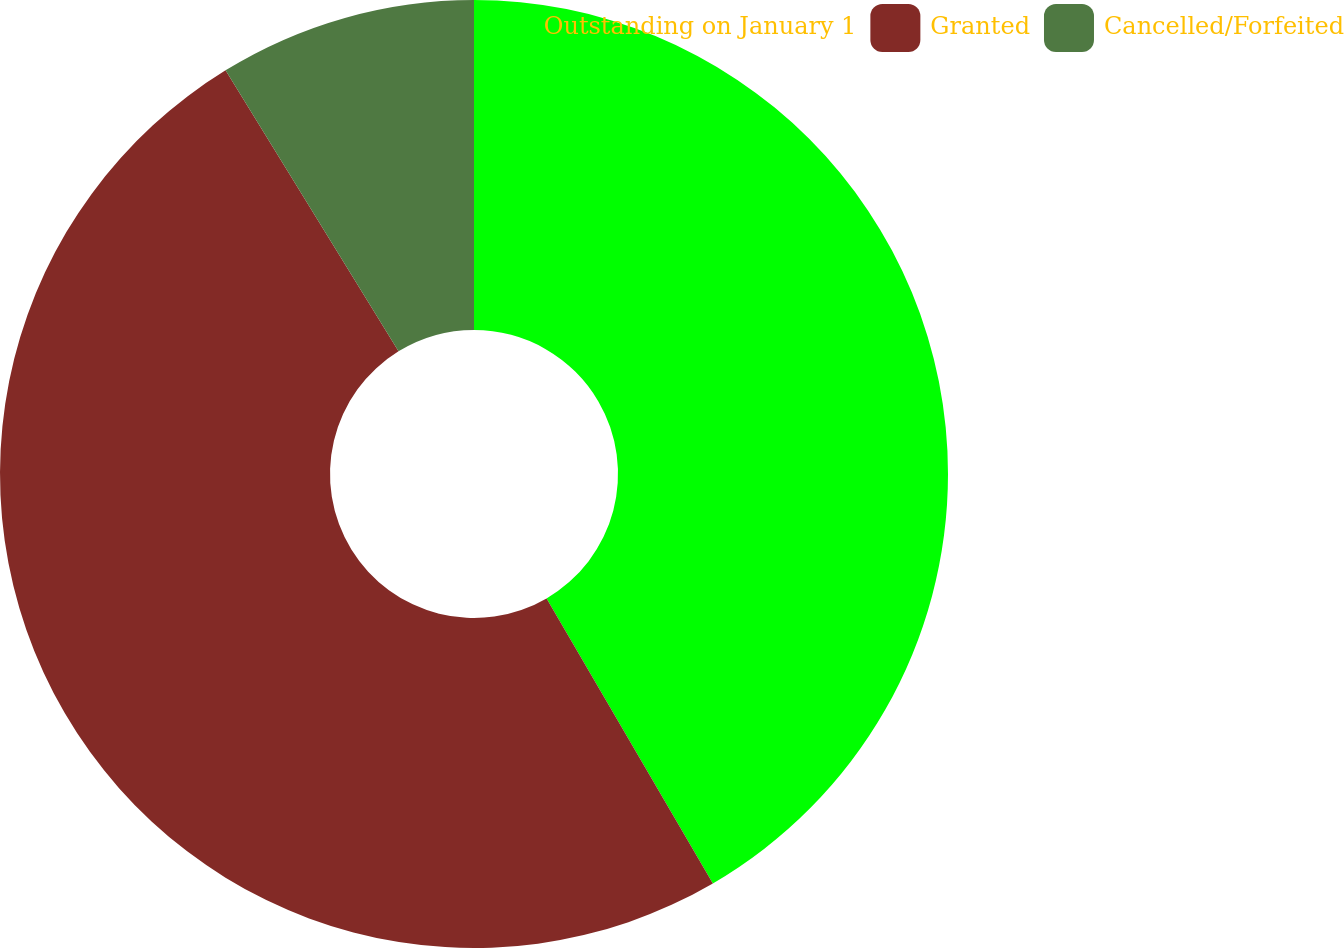Convert chart to OTSL. <chart><loc_0><loc_0><loc_500><loc_500><pie_chart><fcel>Outstanding on January 1<fcel>Granted<fcel>Cancelled/Forfeited<nl><fcel>41.59%<fcel>49.62%<fcel>8.78%<nl></chart> 